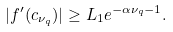<formula> <loc_0><loc_0><loc_500><loc_500>| f ^ { \prime } ( c _ { \nu _ { q } } ) | \geq L _ { 1 } e ^ { - \alpha \nu _ { q } - 1 } .</formula> 